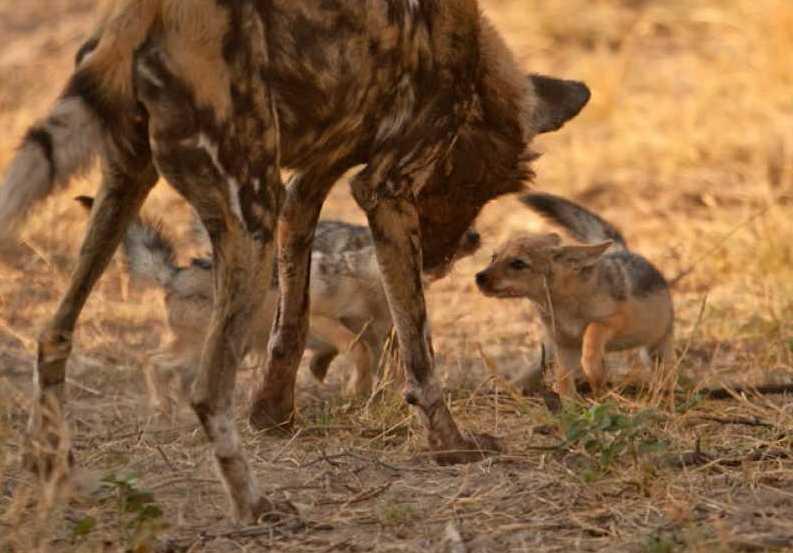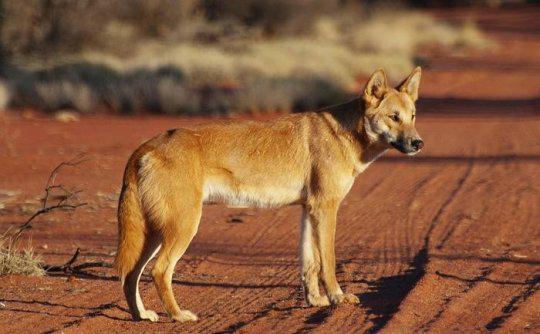The first image is the image on the left, the second image is the image on the right. Examine the images to the left and right. Is the description "A total of two canines are shown." accurate? Answer yes or no. No. 